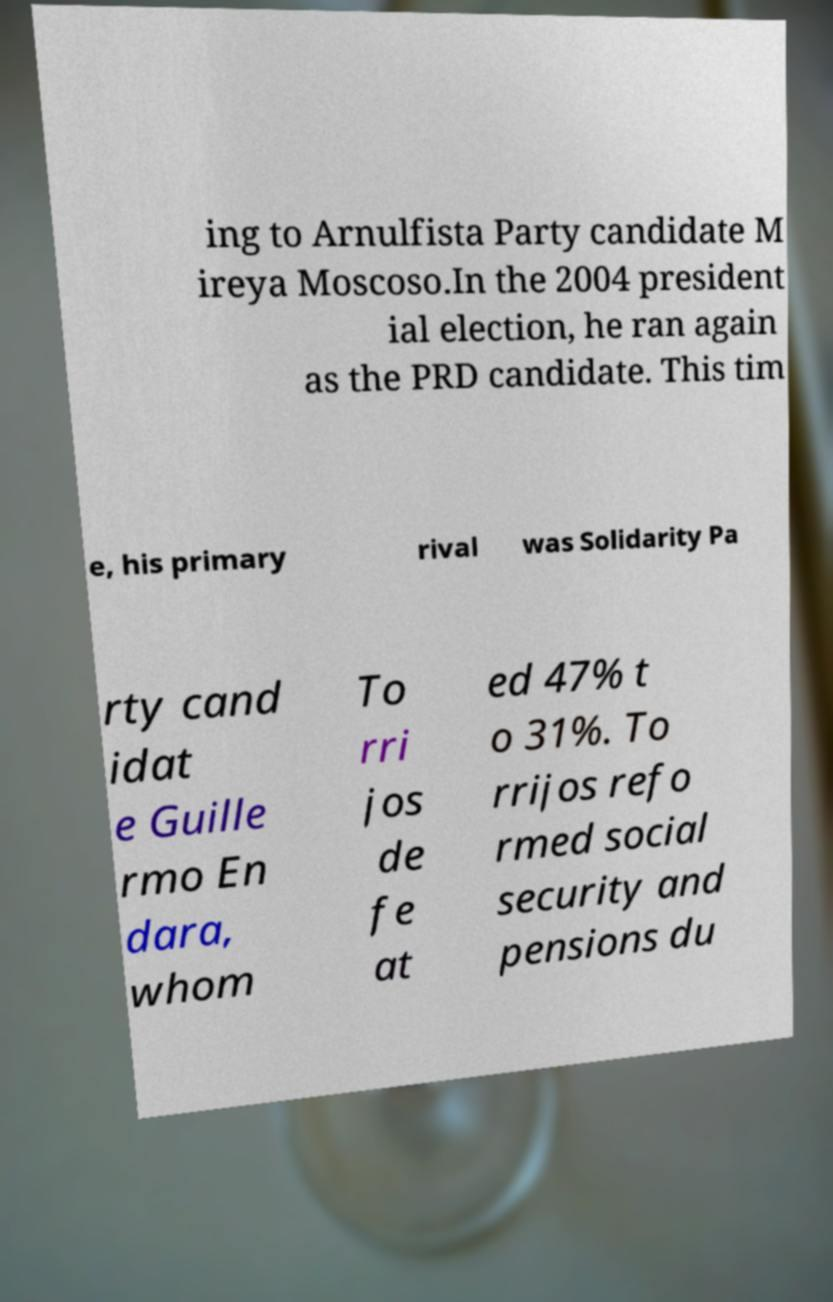Could you extract and type out the text from this image? ing to Arnulfista Party candidate M ireya Moscoso.In the 2004 president ial election, he ran again as the PRD candidate. This tim e, his primary rival was Solidarity Pa rty cand idat e Guille rmo En dara, whom To rri jos de fe at ed 47% t o 31%. To rrijos refo rmed social security and pensions du 